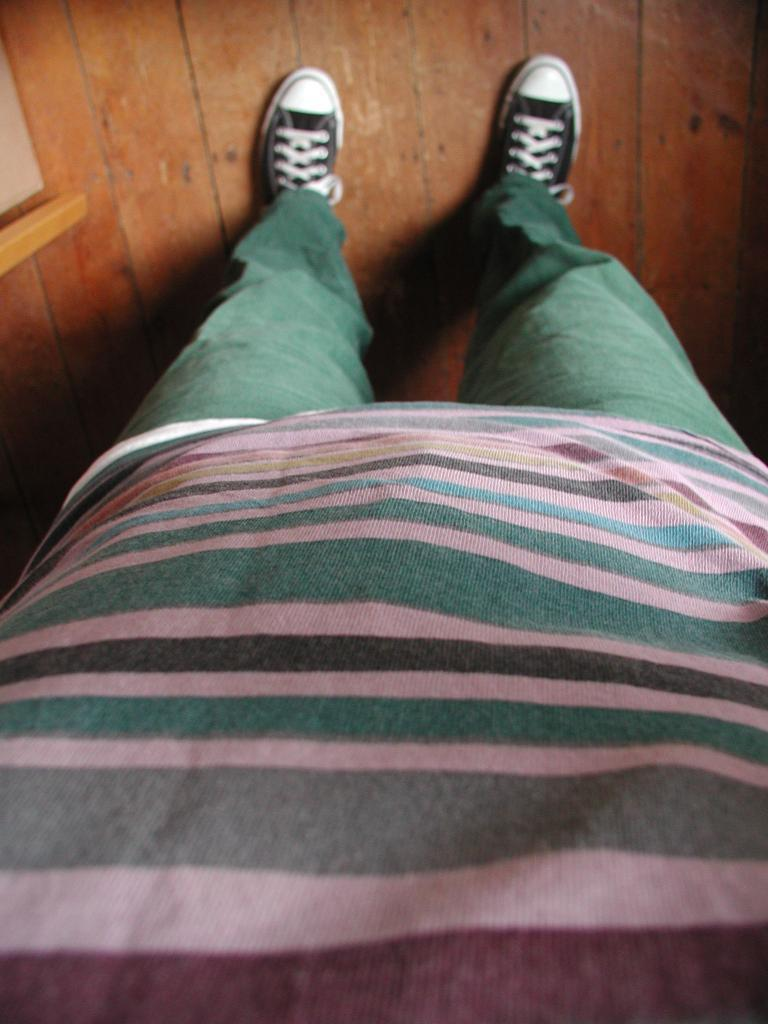What is the person in the image wearing on their upper body? The person is wearing a t-shirt. What color are the pants the person is wearing? The person is wearing green pants. What type of shoes is the person wearing? The person is wearing a pair of black shoes. What material is the floor made of in the image? The floor is made of wood. What stage of development is the family in the image currently experiencing? There is no family present in the image, only a person standing. What type of suit is the person wearing in the image? The person is not wearing a suit in the image; they are wearing a t-shirt and green pants. 